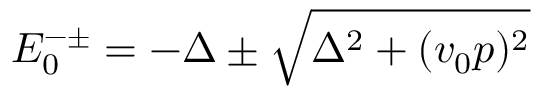Convert formula to latex. <formula><loc_0><loc_0><loc_500><loc_500>E _ { 0 } ^ { - \pm } = - \Delta \pm \sqrt { \Delta ^ { 2 } + ( v _ { 0 } p ) ^ { 2 } }</formula> 